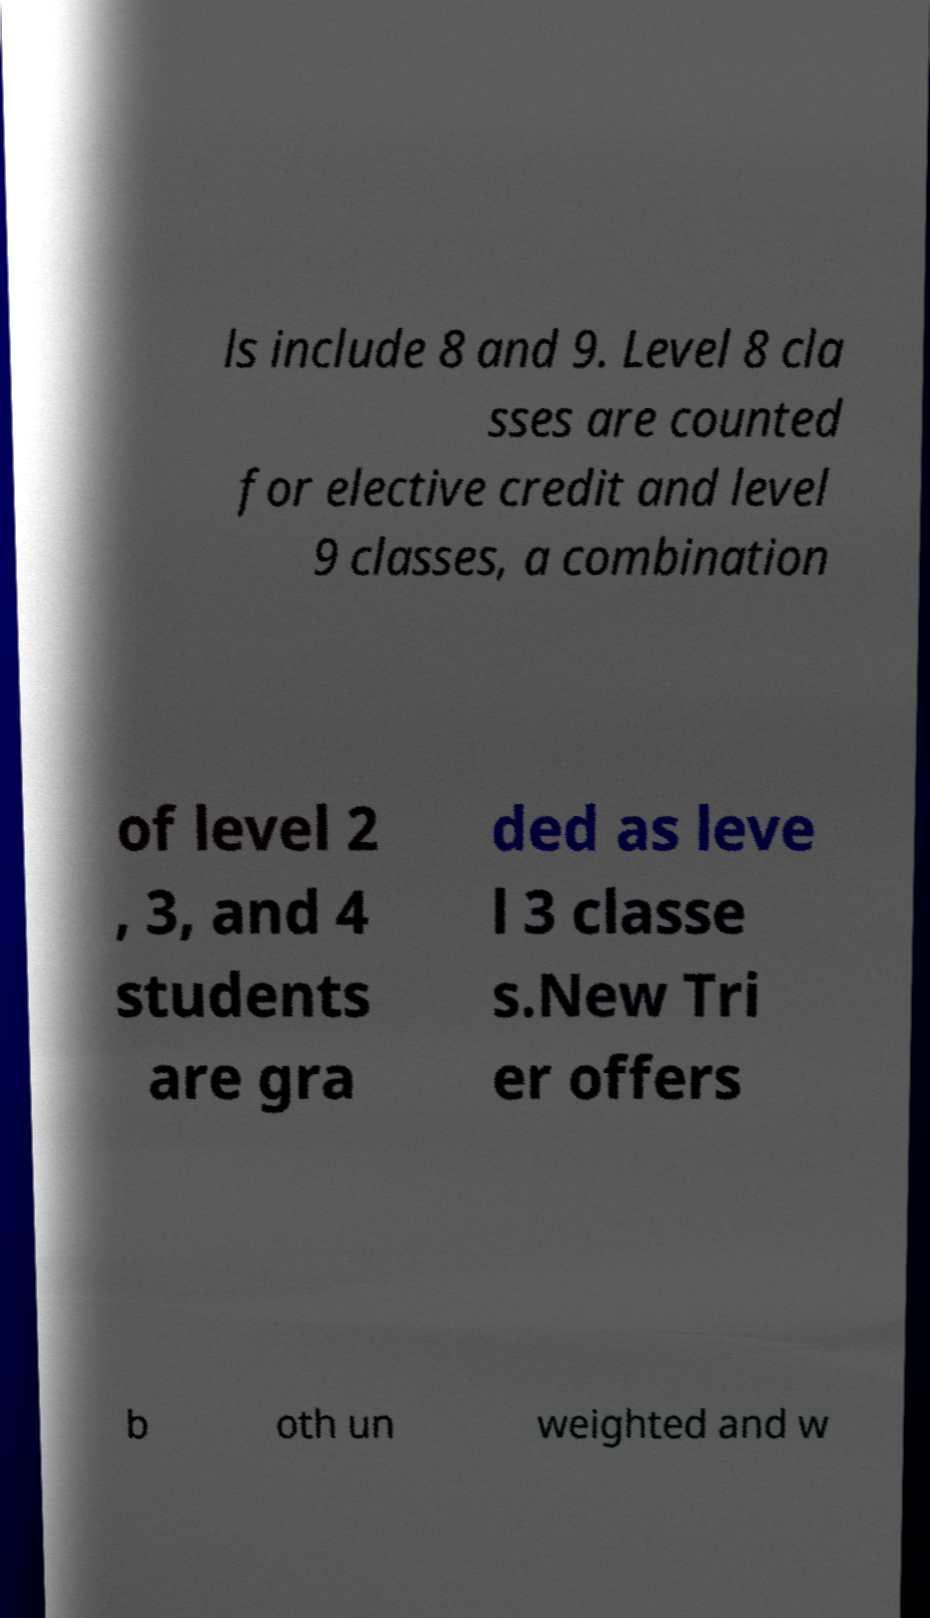There's text embedded in this image that I need extracted. Can you transcribe it verbatim? ls include 8 and 9. Level 8 cla sses are counted for elective credit and level 9 classes, a combination of level 2 , 3, and 4 students are gra ded as leve l 3 classe s.New Tri er offers b oth un weighted and w 